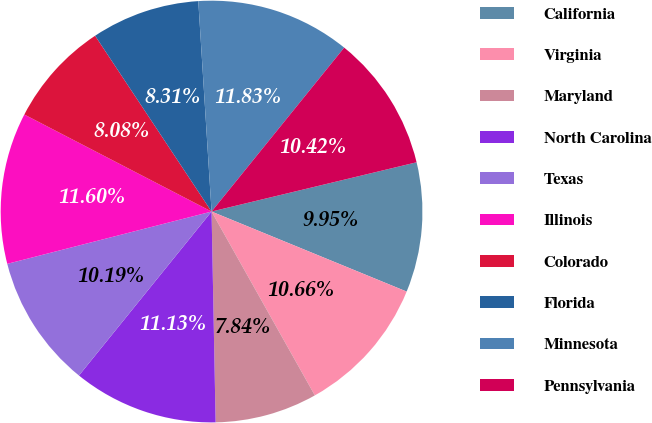Convert chart to OTSL. <chart><loc_0><loc_0><loc_500><loc_500><pie_chart><fcel>California<fcel>Virginia<fcel>Maryland<fcel>North Carolina<fcel>Texas<fcel>Illinois<fcel>Colorado<fcel>Florida<fcel>Minnesota<fcel>Pennsylvania<nl><fcel>9.95%<fcel>10.66%<fcel>7.84%<fcel>11.13%<fcel>10.19%<fcel>11.6%<fcel>8.08%<fcel>8.31%<fcel>11.83%<fcel>10.42%<nl></chart> 